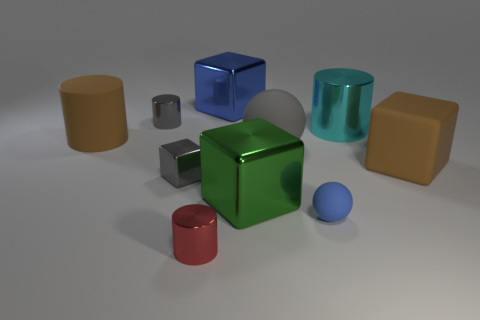Subtract all large green cubes. How many cubes are left? 3 Subtract all red cylinders. How many cylinders are left? 3 Subtract all balls. How many objects are left? 8 Subtract all red cylinders. Subtract all green cubes. How many cylinders are left? 3 Subtract all purple spheres. How many brown cylinders are left? 1 Subtract all tiny cyan metal cylinders. Subtract all large gray balls. How many objects are left? 9 Add 4 gray shiny cylinders. How many gray shiny cylinders are left? 5 Add 9 big cyan metal cylinders. How many big cyan metal cylinders exist? 10 Subtract 1 brown blocks. How many objects are left? 9 Subtract 3 cylinders. How many cylinders are left? 1 